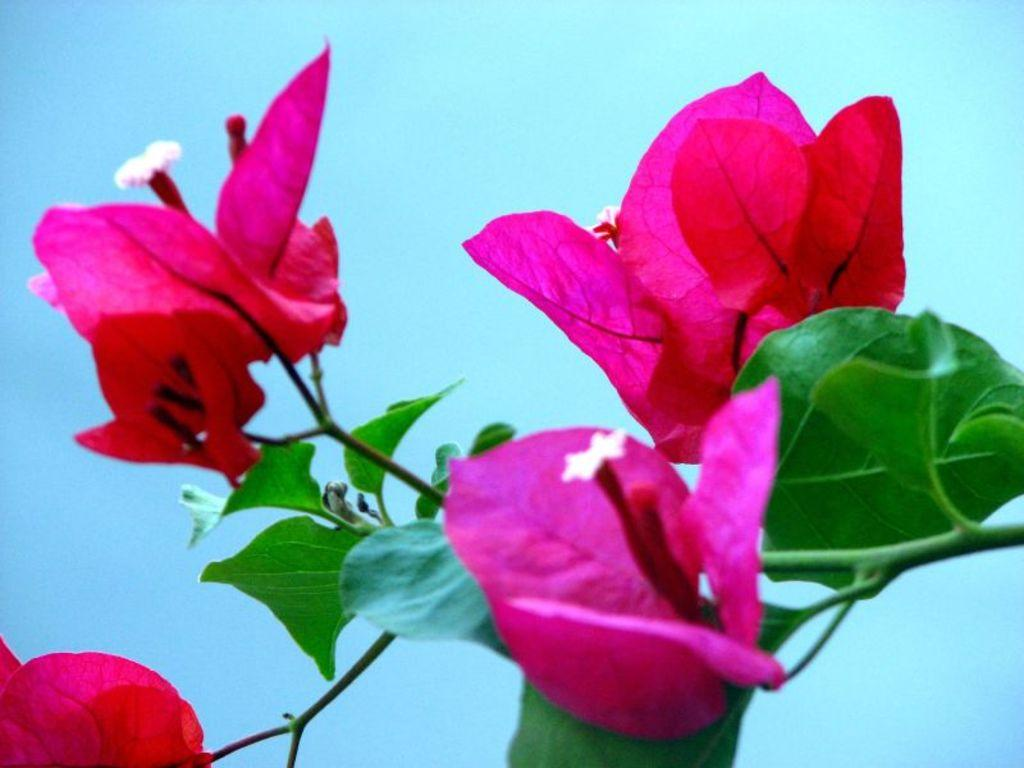What type of flowers are in the middle of the image? There are pink flowers in the middle of the image. What color are the leaves on the right side of the image? The leaves on the right side of the image are green. What type of steel is used to construct the spacecraft in the image? There is no spacecraft or steel present in the image; it features pink flowers and green leaves. How does the person in the image react to the cry of the animal? There is no person or animal crying in the image; it only contains pink flowers and green leaves. 